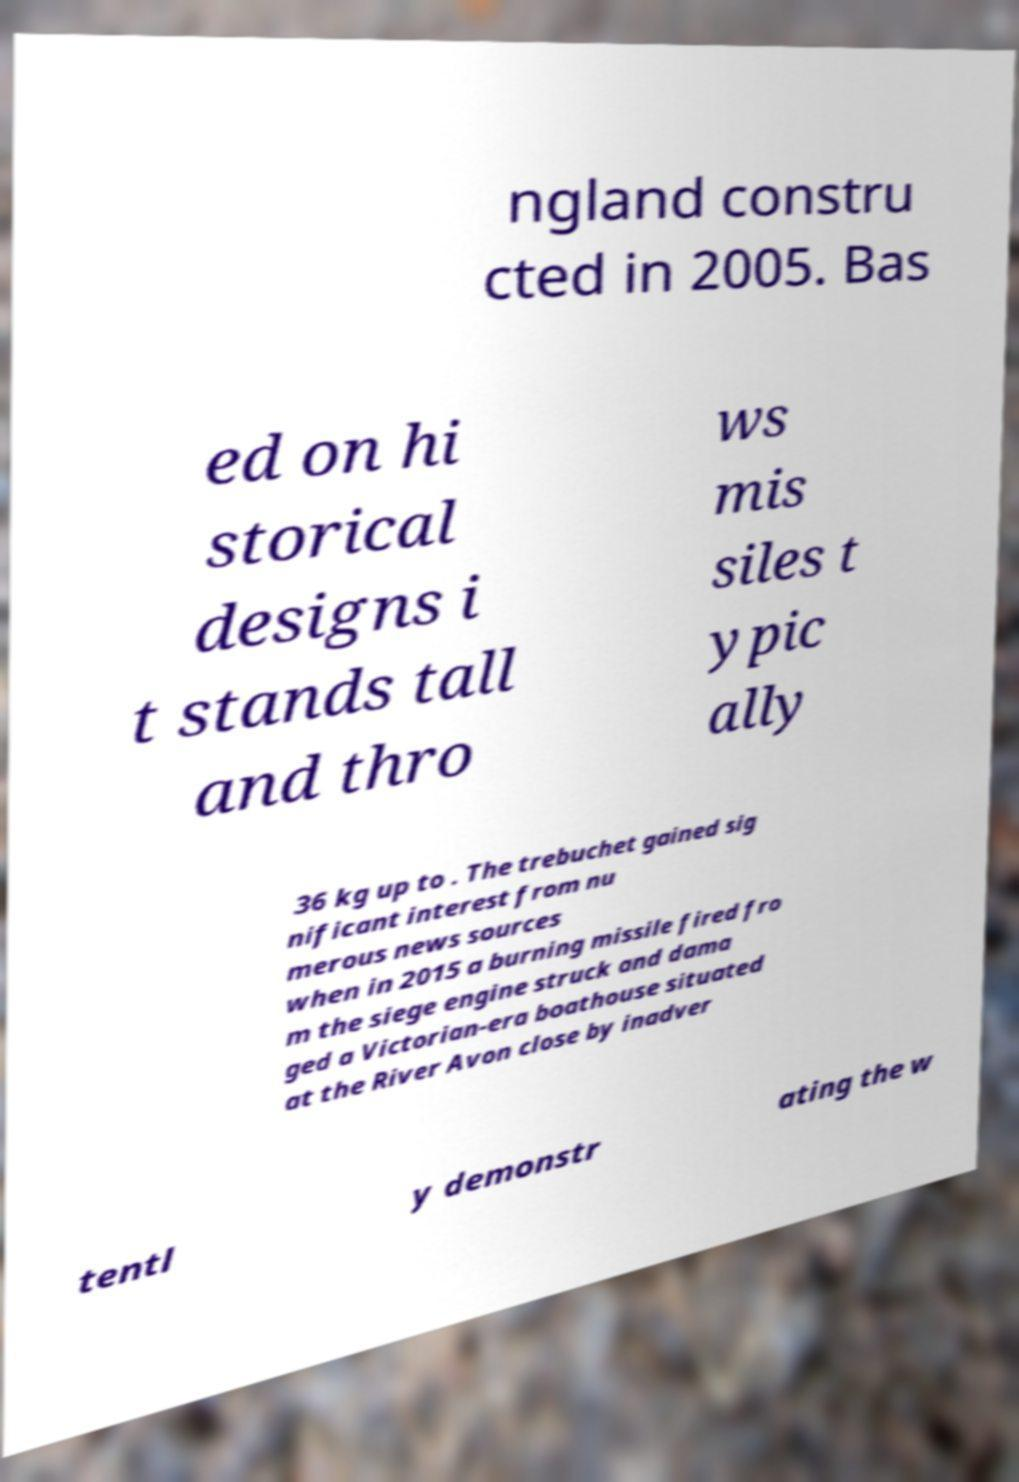Please identify and transcribe the text found in this image. ngland constru cted in 2005. Bas ed on hi storical designs i t stands tall and thro ws mis siles t ypic ally 36 kg up to . The trebuchet gained sig nificant interest from nu merous news sources when in 2015 a burning missile fired fro m the siege engine struck and dama ged a Victorian-era boathouse situated at the River Avon close by inadver tentl y demonstr ating the w 